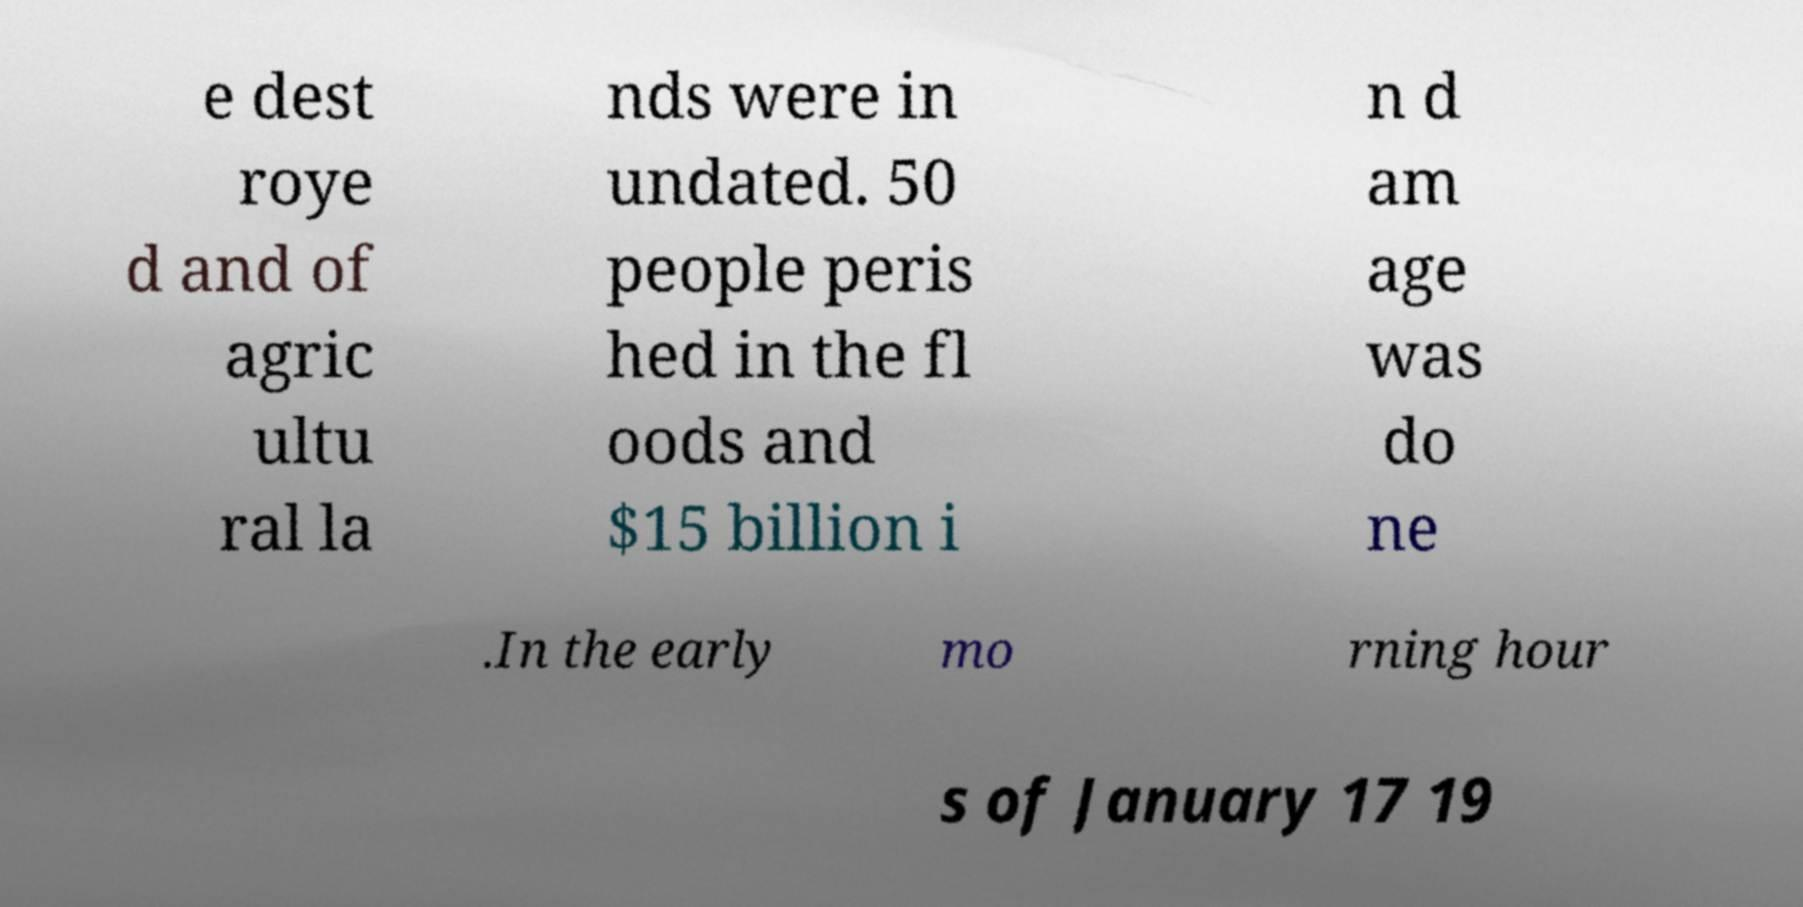Could you extract and type out the text from this image? e dest roye d and of agric ultu ral la nds were in undated. 50 people peris hed in the fl oods and $15 billion i n d am age was do ne .In the early mo rning hour s of January 17 19 